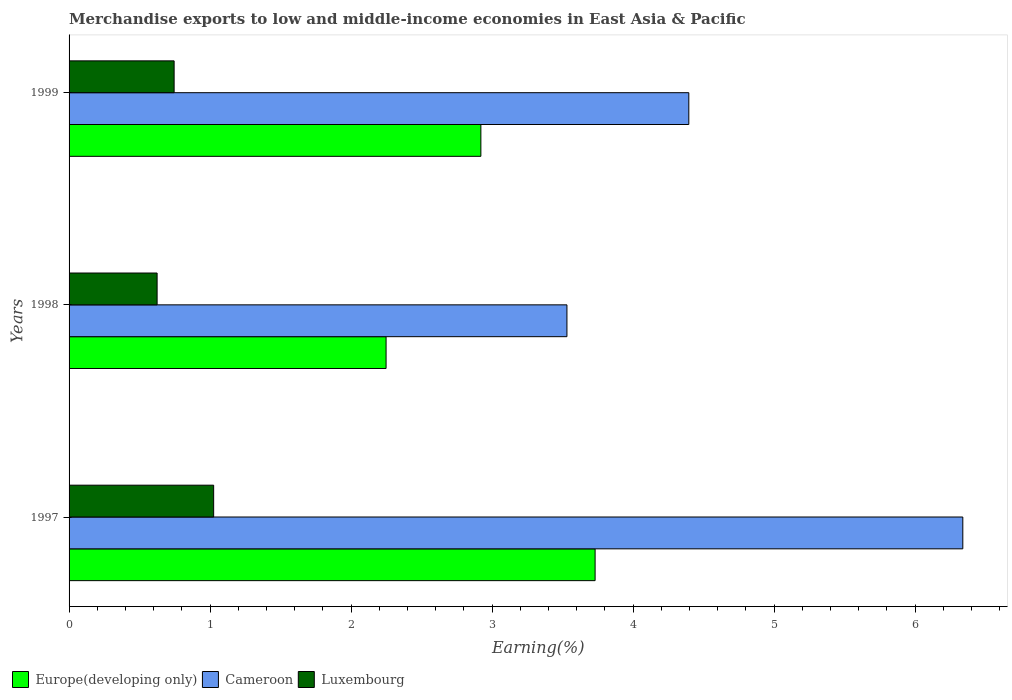Are the number of bars per tick equal to the number of legend labels?
Your response must be concise. Yes. How many bars are there on the 1st tick from the top?
Your response must be concise. 3. How many bars are there on the 1st tick from the bottom?
Make the answer very short. 3. What is the label of the 2nd group of bars from the top?
Your response must be concise. 1998. In how many cases, is the number of bars for a given year not equal to the number of legend labels?
Provide a short and direct response. 0. What is the percentage of amount earned from merchandise exports in Luxembourg in 1999?
Make the answer very short. 0.74. Across all years, what is the maximum percentage of amount earned from merchandise exports in Luxembourg?
Ensure brevity in your answer.  1.03. Across all years, what is the minimum percentage of amount earned from merchandise exports in Cameroon?
Make the answer very short. 3.53. What is the total percentage of amount earned from merchandise exports in Luxembourg in the graph?
Provide a short and direct response. 2.39. What is the difference between the percentage of amount earned from merchandise exports in Europe(developing only) in 1997 and that in 1998?
Provide a succinct answer. 1.48. What is the difference between the percentage of amount earned from merchandise exports in Luxembourg in 1998 and the percentage of amount earned from merchandise exports in Europe(developing only) in 1999?
Ensure brevity in your answer.  -2.3. What is the average percentage of amount earned from merchandise exports in Cameroon per year?
Ensure brevity in your answer.  4.75. In the year 1999, what is the difference between the percentage of amount earned from merchandise exports in Cameroon and percentage of amount earned from merchandise exports in Luxembourg?
Keep it short and to the point. 3.65. In how many years, is the percentage of amount earned from merchandise exports in Europe(developing only) greater than 5.8 %?
Provide a short and direct response. 0. What is the ratio of the percentage of amount earned from merchandise exports in Cameroon in 1997 to that in 1998?
Make the answer very short. 1.8. Is the difference between the percentage of amount earned from merchandise exports in Cameroon in 1997 and 1998 greater than the difference between the percentage of amount earned from merchandise exports in Luxembourg in 1997 and 1998?
Provide a succinct answer. Yes. What is the difference between the highest and the second highest percentage of amount earned from merchandise exports in Europe(developing only)?
Offer a very short reply. 0.81. What is the difference between the highest and the lowest percentage of amount earned from merchandise exports in Europe(developing only)?
Keep it short and to the point. 1.48. In how many years, is the percentage of amount earned from merchandise exports in Cameroon greater than the average percentage of amount earned from merchandise exports in Cameroon taken over all years?
Your answer should be very brief. 1. Is the sum of the percentage of amount earned from merchandise exports in Europe(developing only) in 1998 and 1999 greater than the maximum percentage of amount earned from merchandise exports in Luxembourg across all years?
Ensure brevity in your answer.  Yes. What does the 1st bar from the top in 1999 represents?
Offer a terse response. Luxembourg. What does the 1st bar from the bottom in 1999 represents?
Provide a short and direct response. Europe(developing only). Is it the case that in every year, the sum of the percentage of amount earned from merchandise exports in Cameroon and percentage of amount earned from merchandise exports in Europe(developing only) is greater than the percentage of amount earned from merchandise exports in Luxembourg?
Offer a terse response. Yes. Are all the bars in the graph horizontal?
Your response must be concise. Yes. What is the difference between two consecutive major ticks on the X-axis?
Offer a very short reply. 1. Does the graph contain any zero values?
Make the answer very short. No. Does the graph contain grids?
Provide a short and direct response. No. How many legend labels are there?
Your answer should be very brief. 3. How are the legend labels stacked?
Offer a very short reply. Horizontal. What is the title of the graph?
Your response must be concise. Merchandise exports to low and middle-income economies in East Asia & Pacific. Does "Latin America(developing only)" appear as one of the legend labels in the graph?
Your answer should be compact. No. What is the label or title of the X-axis?
Keep it short and to the point. Earning(%). What is the label or title of the Y-axis?
Offer a terse response. Years. What is the Earning(%) in Europe(developing only) in 1997?
Your response must be concise. 3.73. What is the Earning(%) of Cameroon in 1997?
Your answer should be compact. 6.34. What is the Earning(%) in Luxembourg in 1997?
Make the answer very short. 1.03. What is the Earning(%) of Europe(developing only) in 1998?
Give a very brief answer. 2.25. What is the Earning(%) of Cameroon in 1998?
Make the answer very short. 3.53. What is the Earning(%) of Luxembourg in 1998?
Provide a succinct answer. 0.62. What is the Earning(%) in Europe(developing only) in 1999?
Ensure brevity in your answer.  2.92. What is the Earning(%) in Cameroon in 1999?
Keep it short and to the point. 4.39. What is the Earning(%) in Luxembourg in 1999?
Make the answer very short. 0.74. Across all years, what is the maximum Earning(%) of Europe(developing only)?
Provide a short and direct response. 3.73. Across all years, what is the maximum Earning(%) of Cameroon?
Your answer should be very brief. 6.34. Across all years, what is the maximum Earning(%) in Luxembourg?
Your answer should be very brief. 1.03. Across all years, what is the minimum Earning(%) in Europe(developing only)?
Ensure brevity in your answer.  2.25. Across all years, what is the minimum Earning(%) of Cameroon?
Provide a short and direct response. 3.53. Across all years, what is the minimum Earning(%) of Luxembourg?
Provide a short and direct response. 0.62. What is the total Earning(%) in Europe(developing only) in the graph?
Provide a succinct answer. 8.9. What is the total Earning(%) in Cameroon in the graph?
Offer a very short reply. 14.26. What is the total Earning(%) in Luxembourg in the graph?
Offer a terse response. 2.39. What is the difference between the Earning(%) in Europe(developing only) in 1997 and that in 1998?
Keep it short and to the point. 1.48. What is the difference between the Earning(%) in Cameroon in 1997 and that in 1998?
Keep it short and to the point. 2.81. What is the difference between the Earning(%) in Luxembourg in 1997 and that in 1998?
Offer a very short reply. 0.4. What is the difference between the Earning(%) in Europe(developing only) in 1997 and that in 1999?
Make the answer very short. 0.81. What is the difference between the Earning(%) of Cameroon in 1997 and that in 1999?
Offer a terse response. 1.94. What is the difference between the Earning(%) in Luxembourg in 1997 and that in 1999?
Keep it short and to the point. 0.28. What is the difference between the Earning(%) of Europe(developing only) in 1998 and that in 1999?
Your answer should be compact. -0.67. What is the difference between the Earning(%) of Cameroon in 1998 and that in 1999?
Offer a very short reply. -0.86. What is the difference between the Earning(%) of Luxembourg in 1998 and that in 1999?
Provide a short and direct response. -0.12. What is the difference between the Earning(%) in Europe(developing only) in 1997 and the Earning(%) in Cameroon in 1998?
Offer a terse response. 0.2. What is the difference between the Earning(%) of Europe(developing only) in 1997 and the Earning(%) of Luxembourg in 1998?
Ensure brevity in your answer.  3.11. What is the difference between the Earning(%) in Cameroon in 1997 and the Earning(%) in Luxembourg in 1998?
Provide a short and direct response. 5.71. What is the difference between the Earning(%) in Europe(developing only) in 1997 and the Earning(%) in Cameroon in 1999?
Keep it short and to the point. -0.66. What is the difference between the Earning(%) in Europe(developing only) in 1997 and the Earning(%) in Luxembourg in 1999?
Your answer should be very brief. 2.99. What is the difference between the Earning(%) of Cameroon in 1997 and the Earning(%) of Luxembourg in 1999?
Make the answer very short. 5.59. What is the difference between the Earning(%) in Europe(developing only) in 1998 and the Earning(%) in Cameroon in 1999?
Keep it short and to the point. -2.15. What is the difference between the Earning(%) of Europe(developing only) in 1998 and the Earning(%) of Luxembourg in 1999?
Your answer should be very brief. 1.5. What is the difference between the Earning(%) of Cameroon in 1998 and the Earning(%) of Luxembourg in 1999?
Offer a terse response. 2.79. What is the average Earning(%) in Europe(developing only) per year?
Your answer should be very brief. 2.97. What is the average Earning(%) of Cameroon per year?
Offer a very short reply. 4.75. What is the average Earning(%) of Luxembourg per year?
Give a very brief answer. 0.8. In the year 1997, what is the difference between the Earning(%) in Europe(developing only) and Earning(%) in Cameroon?
Provide a succinct answer. -2.61. In the year 1997, what is the difference between the Earning(%) of Europe(developing only) and Earning(%) of Luxembourg?
Make the answer very short. 2.71. In the year 1997, what is the difference between the Earning(%) in Cameroon and Earning(%) in Luxembourg?
Your answer should be very brief. 5.31. In the year 1998, what is the difference between the Earning(%) in Europe(developing only) and Earning(%) in Cameroon?
Your answer should be very brief. -1.28. In the year 1998, what is the difference between the Earning(%) of Europe(developing only) and Earning(%) of Luxembourg?
Make the answer very short. 1.62. In the year 1998, what is the difference between the Earning(%) in Cameroon and Earning(%) in Luxembourg?
Offer a terse response. 2.91. In the year 1999, what is the difference between the Earning(%) of Europe(developing only) and Earning(%) of Cameroon?
Provide a succinct answer. -1.47. In the year 1999, what is the difference between the Earning(%) of Europe(developing only) and Earning(%) of Luxembourg?
Make the answer very short. 2.18. In the year 1999, what is the difference between the Earning(%) in Cameroon and Earning(%) in Luxembourg?
Provide a short and direct response. 3.65. What is the ratio of the Earning(%) in Europe(developing only) in 1997 to that in 1998?
Offer a terse response. 1.66. What is the ratio of the Earning(%) in Cameroon in 1997 to that in 1998?
Ensure brevity in your answer.  1.8. What is the ratio of the Earning(%) of Luxembourg in 1997 to that in 1998?
Your answer should be very brief. 1.64. What is the ratio of the Earning(%) of Europe(developing only) in 1997 to that in 1999?
Offer a very short reply. 1.28. What is the ratio of the Earning(%) in Cameroon in 1997 to that in 1999?
Offer a very short reply. 1.44. What is the ratio of the Earning(%) of Luxembourg in 1997 to that in 1999?
Offer a very short reply. 1.38. What is the ratio of the Earning(%) of Europe(developing only) in 1998 to that in 1999?
Offer a very short reply. 0.77. What is the ratio of the Earning(%) in Cameroon in 1998 to that in 1999?
Provide a succinct answer. 0.8. What is the ratio of the Earning(%) of Luxembourg in 1998 to that in 1999?
Offer a terse response. 0.84. What is the difference between the highest and the second highest Earning(%) of Europe(developing only)?
Your answer should be very brief. 0.81. What is the difference between the highest and the second highest Earning(%) of Cameroon?
Your answer should be compact. 1.94. What is the difference between the highest and the second highest Earning(%) of Luxembourg?
Offer a very short reply. 0.28. What is the difference between the highest and the lowest Earning(%) in Europe(developing only)?
Offer a very short reply. 1.48. What is the difference between the highest and the lowest Earning(%) in Cameroon?
Keep it short and to the point. 2.81. What is the difference between the highest and the lowest Earning(%) in Luxembourg?
Give a very brief answer. 0.4. 